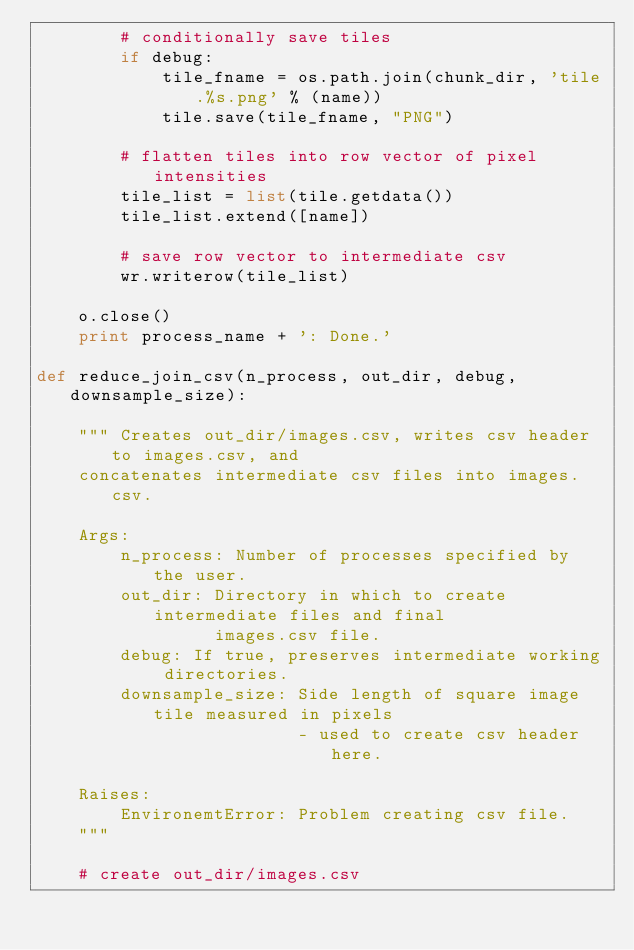<code> <loc_0><loc_0><loc_500><loc_500><_Python_>        # conditionally save tiles                                
        if debug:
            tile_fname = os.path.join(chunk_dir, 'tile.%s.png' % (name))
            tile.save(tile_fname, "PNG")

        # flatten tiles into row vector of pixel intensities
        tile_list = list(tile.getdata())
        tile_list.extend([name])

        # save row vector to intermediate csv
        wr.writerow(tile_list)

    o.close()
    print process_name + ': Done.'
    
def reduce_join_csv(n_process, out_dir, debug, downsample_size):

    """ Creates out_dir/images.csv, writes csv header to images.csv, and
    concatenates intermediate csv files into images.csv.

    Args:
        n_process: Number of processes specified by the user.
        out_dir: Directory in which to create intermediate files and final
                 images.csv file.
        debug: If true, preserves intermediate working directories.
        downsample_size: Side length of square image tile measured in pixels
                         - used to create csv header here.

    Raises:
        EnvironemtError: Problem creating csv file.
    """

    # create out_dir/images.csv</code> 